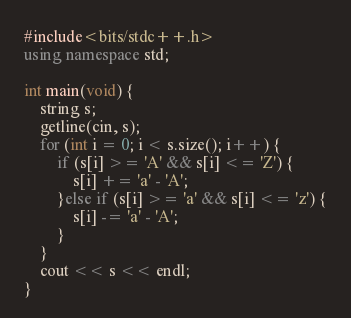Convert code to text. <code><loc_0><loc_0><loc_500><loc_500><_C++_>#include<bits/stdc++.h>
using namespace std;

int main(void) {
    string s;
    getline(cin, s);
    for (int i = 0; i < s.size(); i++) {
        if (s[i] >= 'A' && s[i] <= 'Z') {
            s[i] += 'a' - 'A';
        }else if (s[i] >= 'a' && s[i] <= 'z') {
            s[i] -= 'a' - 'A';
        }
    }
    cout << s << endl;
}
</code> 